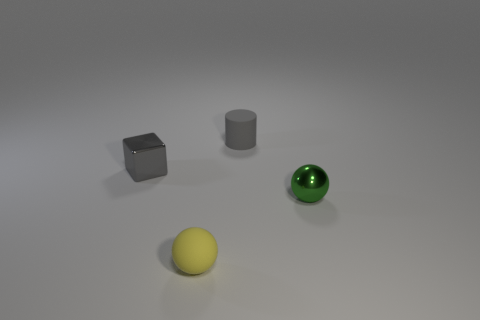What is the color of the object that is in front of the gray matte cylinder and right of the yellow ball?
Offer a very short reply. Green. Is there any other thing of the same color as the tiny cylinder?
Offer a terse response. Yes. There is a small object in front of the metal object that is in front of the tiny gray thing that is on the left side of the tiny yellow matte thing; what is its shape?
Offer a terse response. Sphere. There is a matte thing that is the same shape as the green metallic object; what is its color?
Give a very brief answer. Yellow. There is a small matte thing that is behind the tiny gray thing in front of the cylinder; what color is it?
Offer a terse response. Gray. What is the size of the yellow thing that is the same shape as the green shiny object?
Your response must be concise. Small. What number of gray cylinders are made of the same material as the block?
Your response must be concise. 0. What number of small yellow rubber objects are on the left side of the small gray rubber cylinder that is to the right of the small metallic block?
Your answer should be very brief. 1. Are there any yellow objects behind the small gray rubber thing?
Ensure brevity in your answer.  No. Does the shiny object that is in front of the shiny cube have the same shape as the gray shiny object?
Provide a short and direct response. No. 